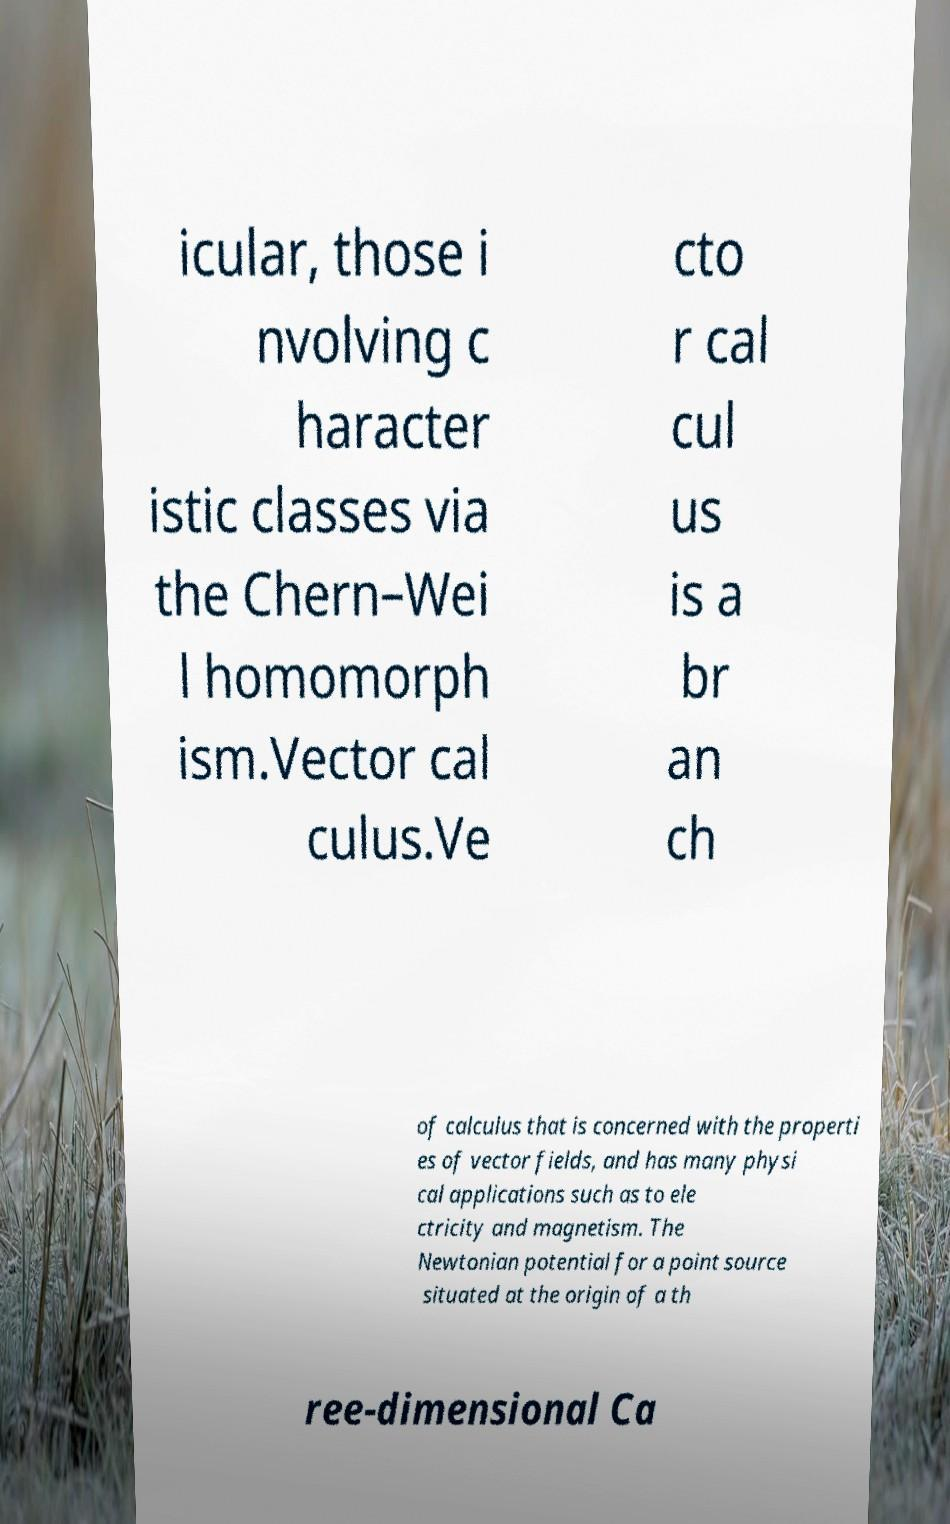I need the written content from this picture converted into text. Can you do that? icular, those i nvolving c haracter istic classes via the Chern–Wei l homomorph ism.Vector cal culus.Ve cto r cal cul us is a br an ch of calculus that is concerned with the properti es of vector fields, and has many physi cal applications such as to ele ctricity and magnetism. The Newtonian potential for a point source situated at the origin of a th ree-dimensional Ca 